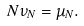<formula> <loc_0><loc_0><loc_500><loc_500>N \nu _ { N } = \mu _ { N } .</formula> 